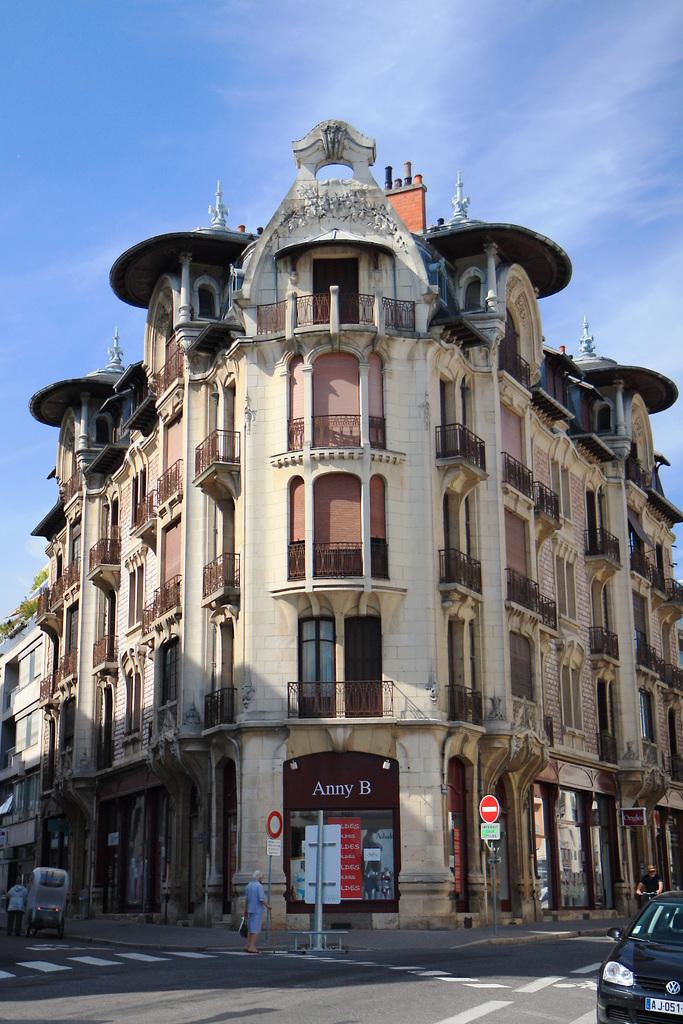What is the main structure in the picture? There is a building in the picture. What else can be seen in the picture besides the building? Cars are moving in the picture, and there is a woman standing in the picture. How would you describe the weather in the picture? The sky is clear in the picture, suggesting good weather. Can you tell me what type of patch the doctor is wearing in the picture? There is no doctor or patch present in the image. How many drops of rain can be seen falling in the picture? There are no drops of rain visible in the image, as the sky is clear. 